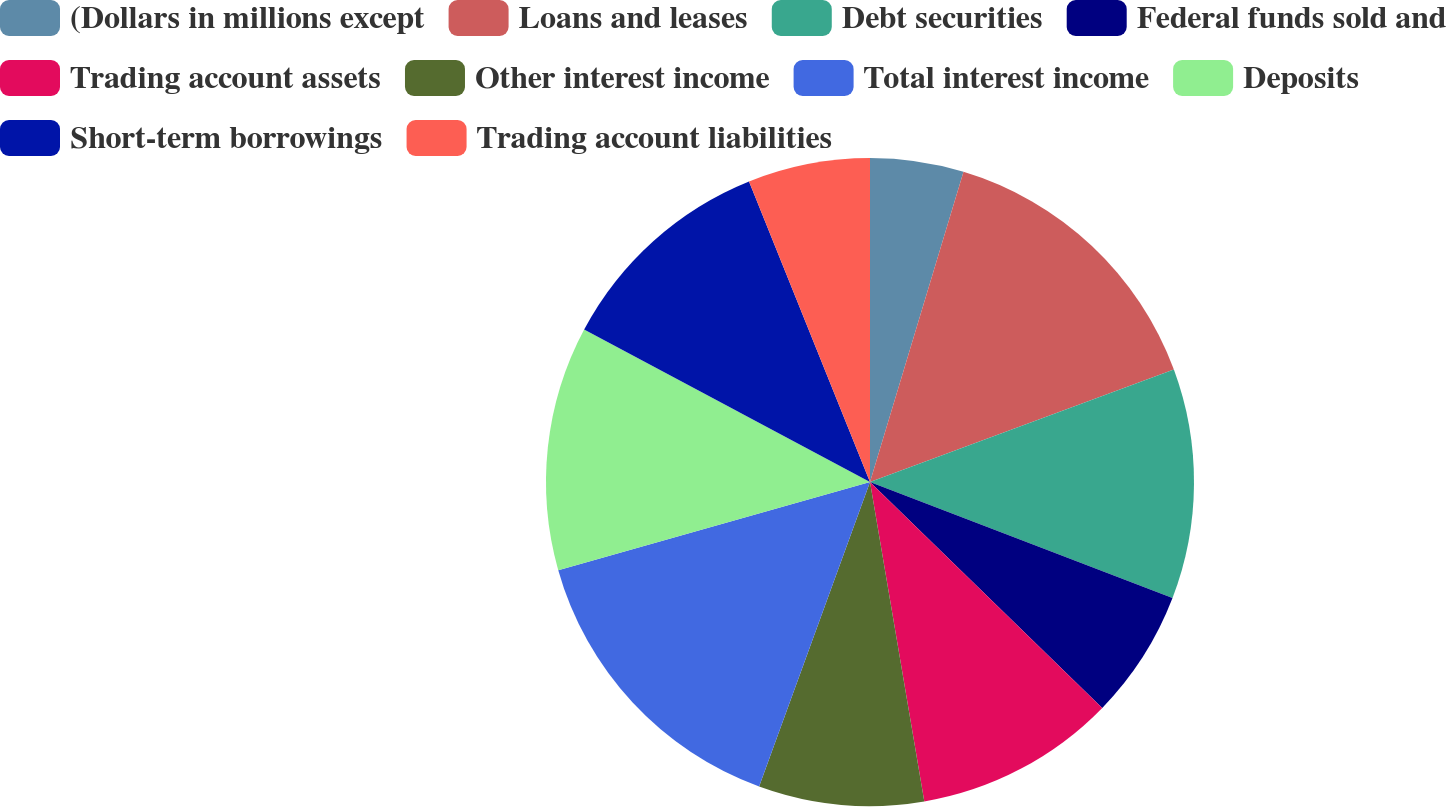<chart> <loc_0><loc_0><loc_500><loc_500><pie_chart><fcel>(Dollars in millions except<fcel>Loans and leases<fcel>Debt securities<fcel>Federal funds sold and<fcel>Trading account assets<fcel>Other interest income<fcel>Total interest income<fcel>Deposits<fcel>Short-term borrowings<fcel>Trading account liabilities<nl><fcel>4.66%<fcel>14.7%<fcel>11.47%<fcel>6.45%<fcel>10.04%<fcel>8.24%<fcel>15.05%<fcel>12.19%<fcel>11.11%<fcel>6.09%<nl></chart> 